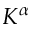<formula> <loc_0><loc_0><loc_500><loc_500>K ^ { \alpha }</formula> 